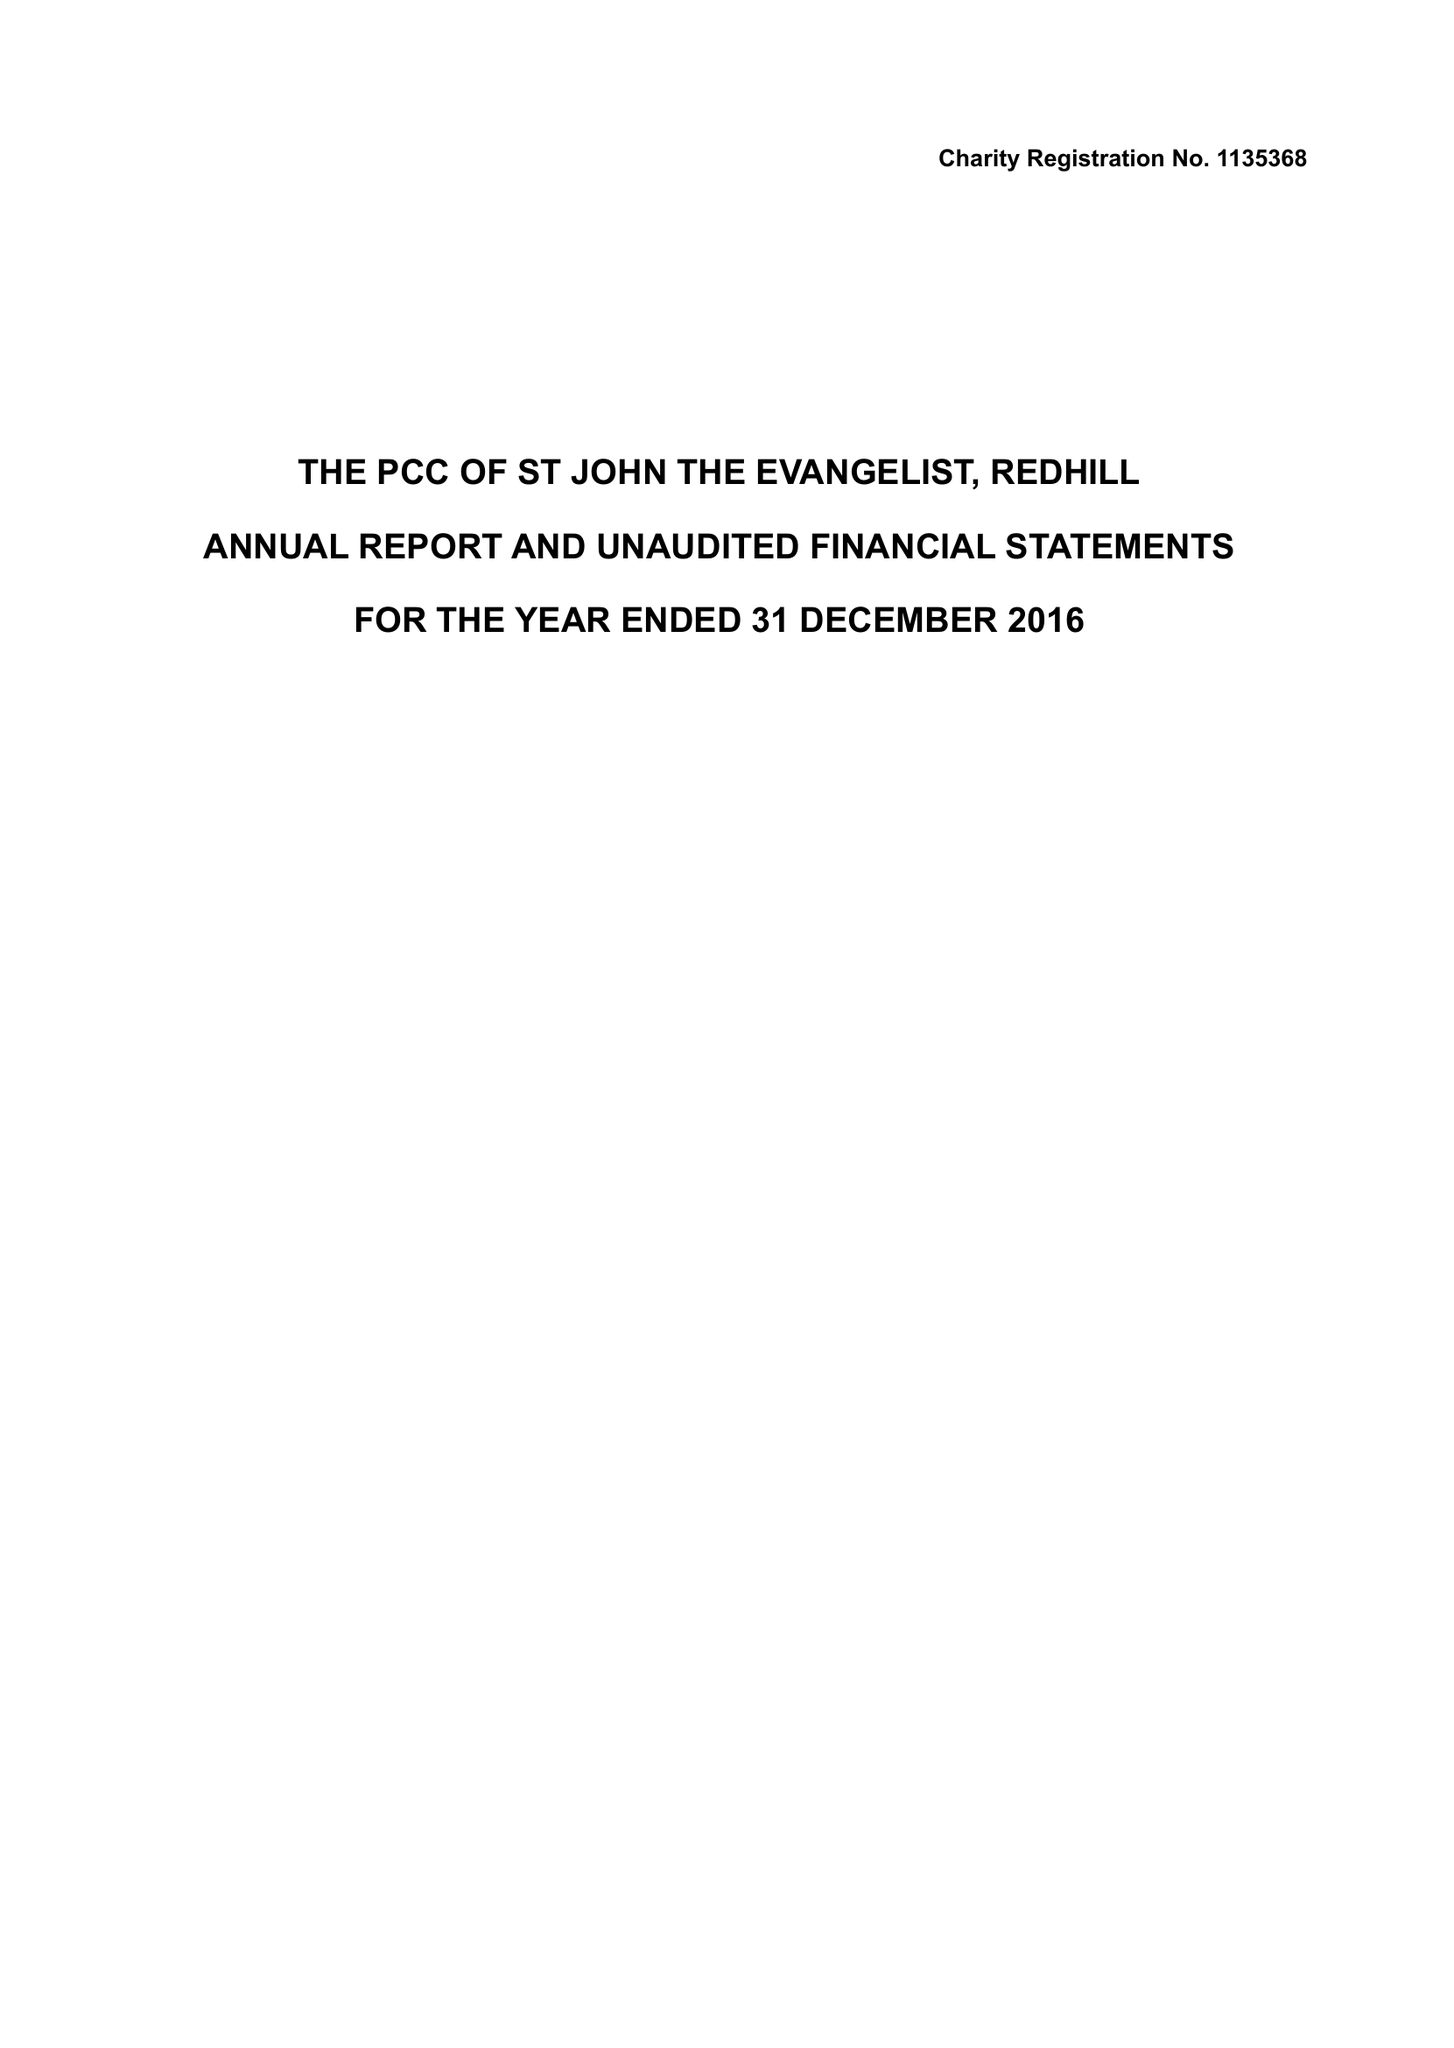What is the value for the address__post_town?
Answer the question using a single word or phrase. REDHILL 